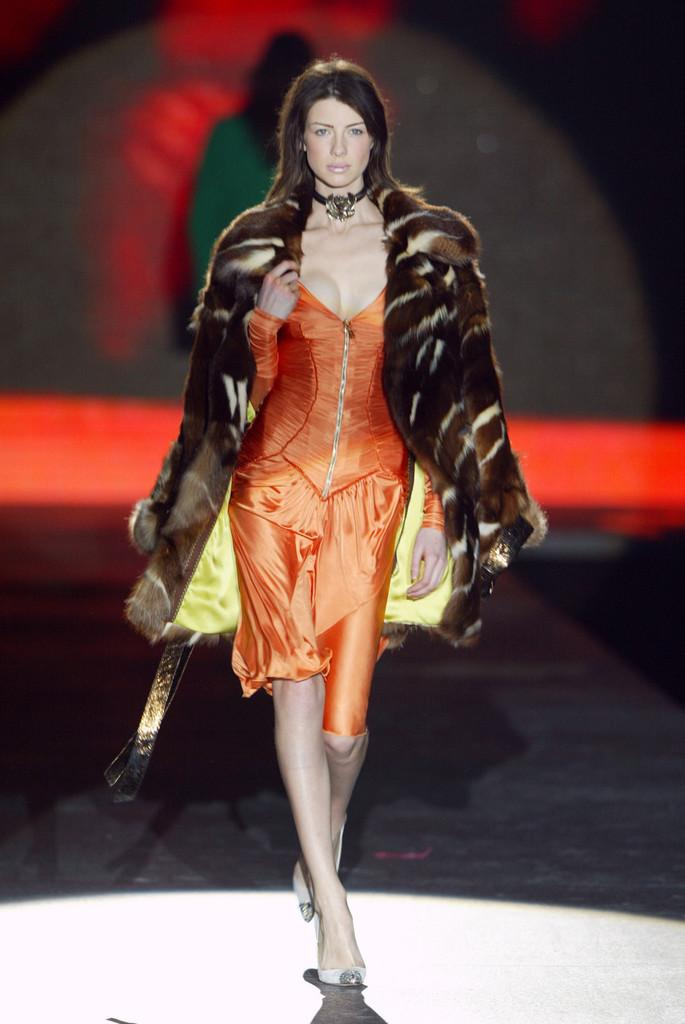How many people are in the image? There are two persons standing in the image. Can you describe the background of the image? The background of the image is blurred. What type of produce is being sorted in the library system in the image? There is no library or produce present in the image; it features two persons standing with a blurred background. 